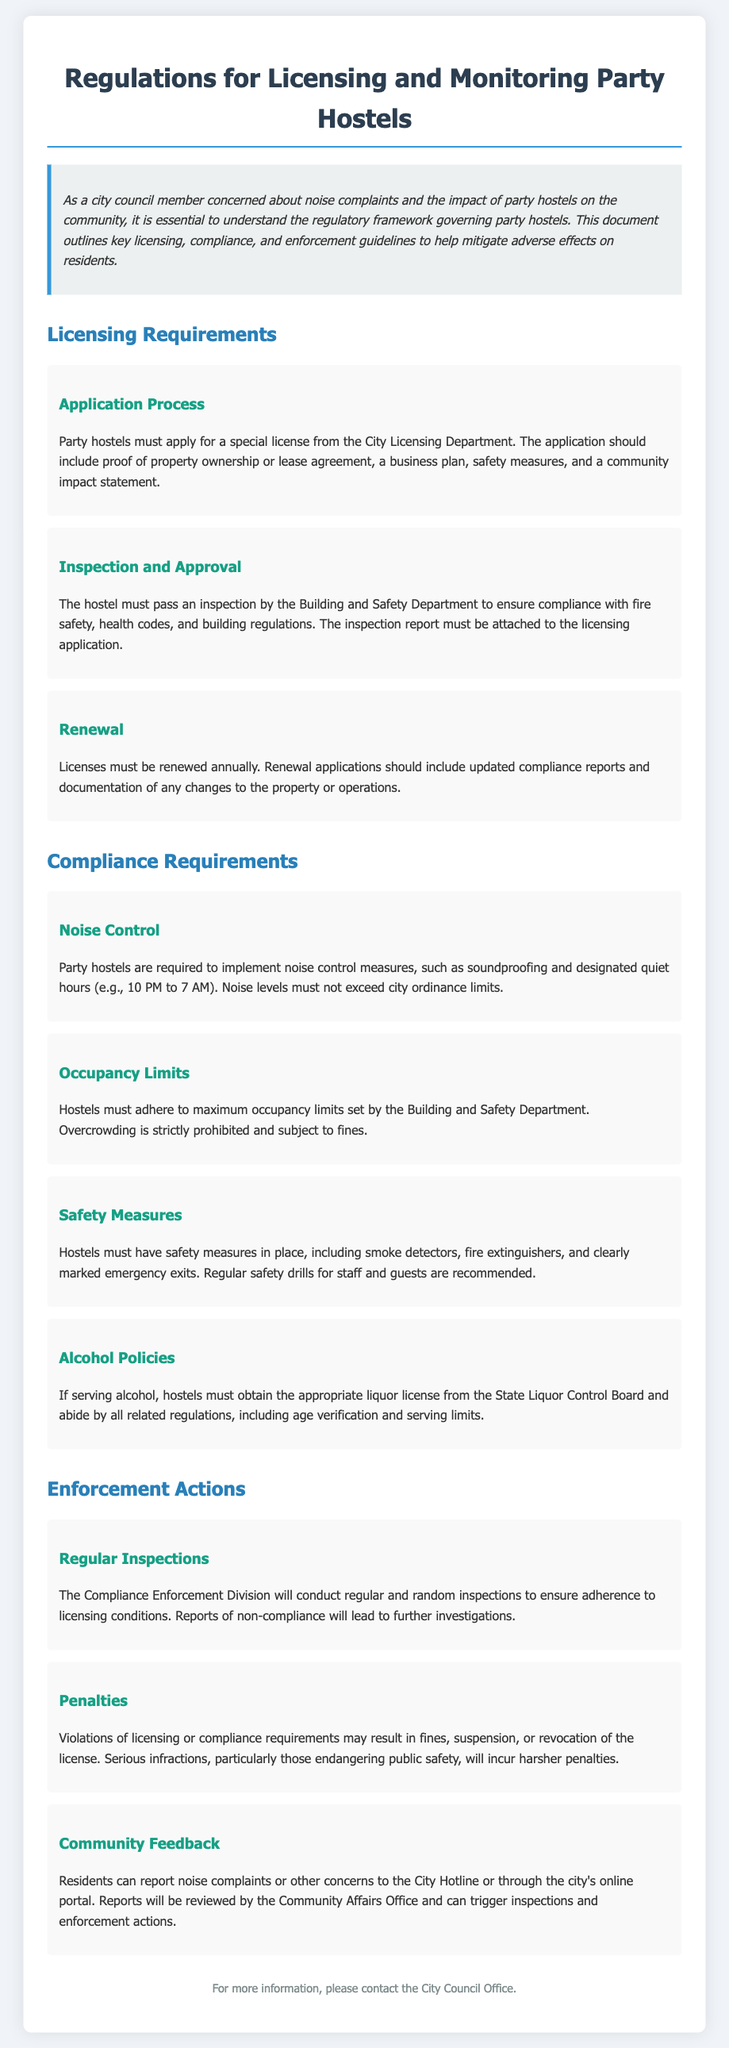What is the document about? The document outlines the regulations for licensing and monitoring party hostels, including compliance requirements and enforcement actions, aimed at mitigating community impacts.
Answer: Regulations for Licensing and Monitoring Party Hostels What department issues the special license? The special license for party hostels must be applied for from the City Licensing Department.
Answer: City Licensing Department What hours are designated as quiet hours? The document specifies quiet hours during which noise control measures must be implemented, particularly for party hostels.
Answer: 10 PM to 7 AM What is required for the renewal of licenses? The renewal applications should include updated compliance reports and documentation of any changes to the property or operations.
Answer: Updated compliance reports and documentation What can happen in case of serious infractions? Serious infractions, particularly those endangering public safety, will incur harsher penalties according to the enforcement actions outlined in the document.
Answer: Harsher penalties What must hostels have in place for safety? The document states that party hostels must have safety measures such as smoke detectors and fire extinguishers.
Answer: Smoke detectors and fire extinguishers How often will the Compliance Enforcement Division conduct inspections? The document mentions that the Compliance Enforcement Division conducts regular and random inspections to ensure compliance.
Answer: Regular and random inspections Who can report noise complaints? Residents can report noise complaints or other concerns to the City Hotline or through the city's online portal.
Answer: Residents 